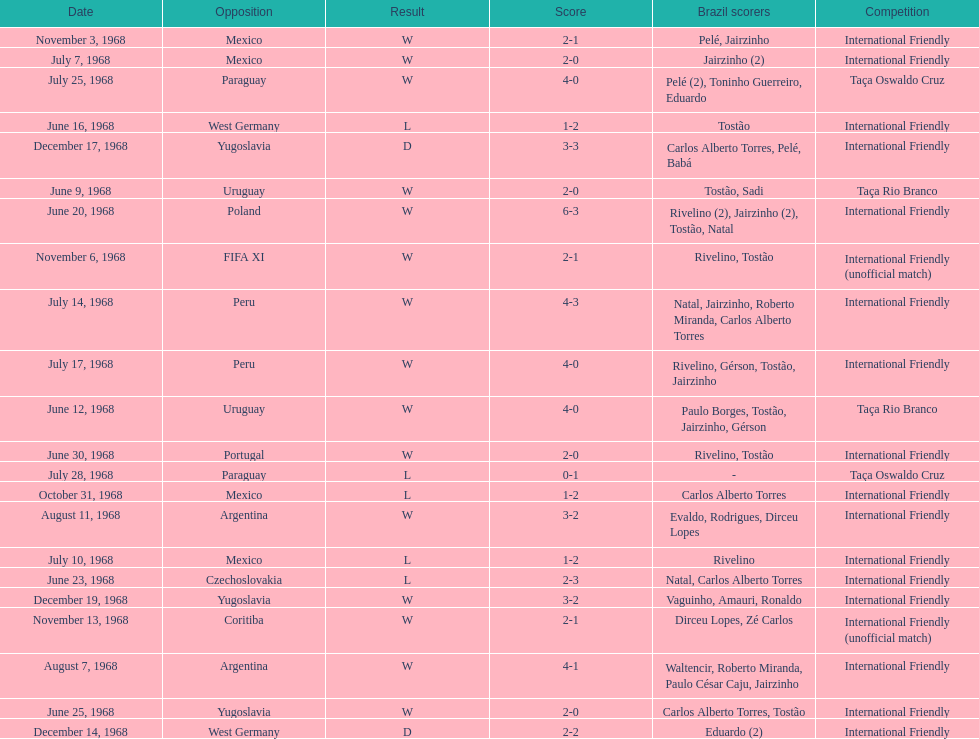The most goals scored by brazil in a game 6. 